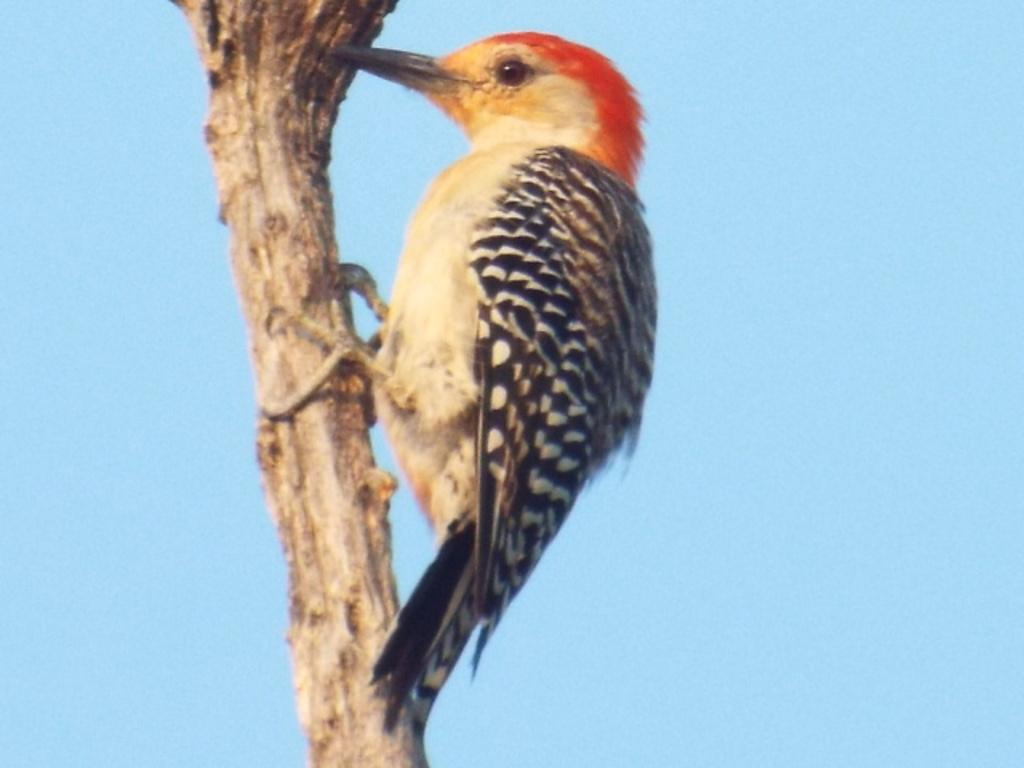What is the main subject in the foreground of the image? There is a bird in the foreground of the image. Where is the bird located in the image? The bird is on a stem. What can be seen in the background of the image? The sky is visible in the background of the image. What type of pipe is being used by the bird in the image? There is no pipe present in the image; the bird is on a stem. What is the plot of the story being told by the bird in the image? There is no story being told by the bird in the image; it is simply perched on a stem. 